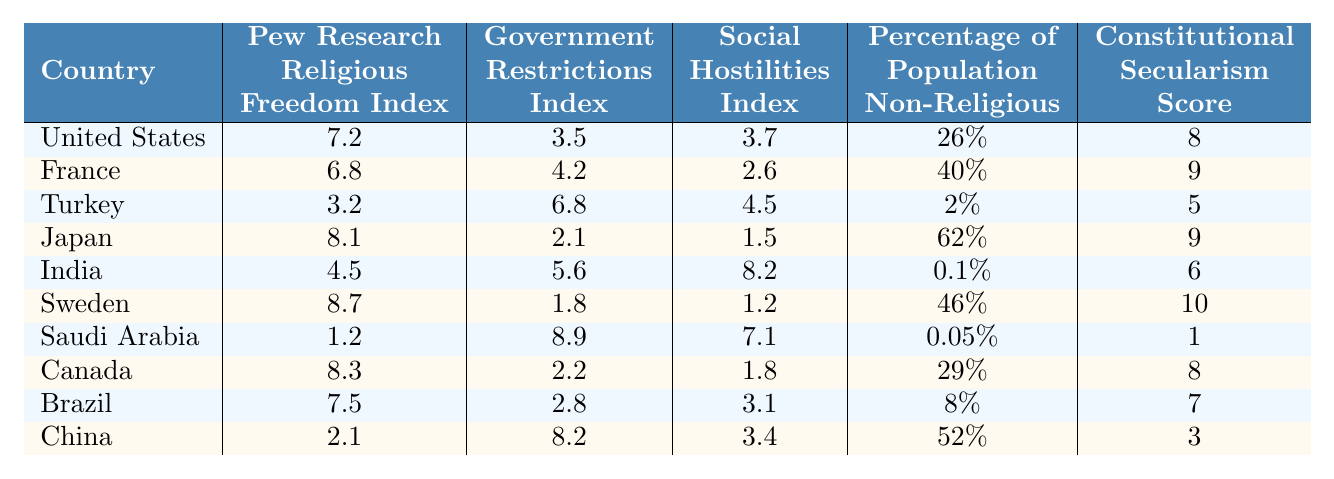What is the Pew Research Religious Freedom Index score of Japan? The table lists Japan's Pew Research Religious Freedom Index score as 8.1.
Answer: 8.1 Which country has the highest Government Restrictions Index? Saudi Arabia has the highest Government Restrictions Index score of 8.9.
Answer: Saudi Arabia What is the average percentage of the population identifying as non-religious across all countries listed? The percentages are 26, 40, 2, 62, 0.1, 46, 0.05, 29, 8, and 52. Summing these yields 263.25, and there are 10 countries, so the average is 263.25 / 10 = 26.325%.
Answer: 26.33% Is the Constitutional Secularism Score of Turkey higher than that of India? Turkey has a score of 5 while India has a score of 6, so Turkey's score is not higher than India's.
Answer: No What can you infer about the relationship between the Pew Research Religious Freedom Index and the Government Restrictions Index based on the data? By observing the scores, countries that have a higher Pew Research Index tend to have a lower Government Restrictions Index. For example, Japan has the highest Pew Index (8.1) and the lowest Government Restrictions Index (2.1). Conversely, countries with low Pew Index scores, like Saudi Arabia (1.2), have high Government Restrictions Index scores (8.9). This suggests an inverse relationship between these two indices.
Answer: Inverse relationship Which country has the lowest Social Hostilities Index? The table indicates that Japan has the lowest Social Hostilities Index, with a score of 1.5.
Answer: Japan What is the difference between the Pew Research Religious Freedom Index of Sweden and China? Sweden's index is 8.7 and China's is 2.1; the difference is calculated as 8.7 - 2.1 = 6.6.
Answer: 6.6 True or False: France's percentage of the population identifying as non-religious is greater than that of the United States. France's percentage is 40%, while the United States' is 26%, which confirms that France's is greater.
Answer: True Which country shows the highest percentage of the population identifying as non-religious? Japan has the highest percentage of non-religious individuals at 62%.
Answer: Japan How do the Constitutional Secularism Scores of Canada and Brazil compare? Canada has a score of 8, while Brazil has a score of 7, indicating Canada has a higher score than Brazil.
Answer: Canada is higher 